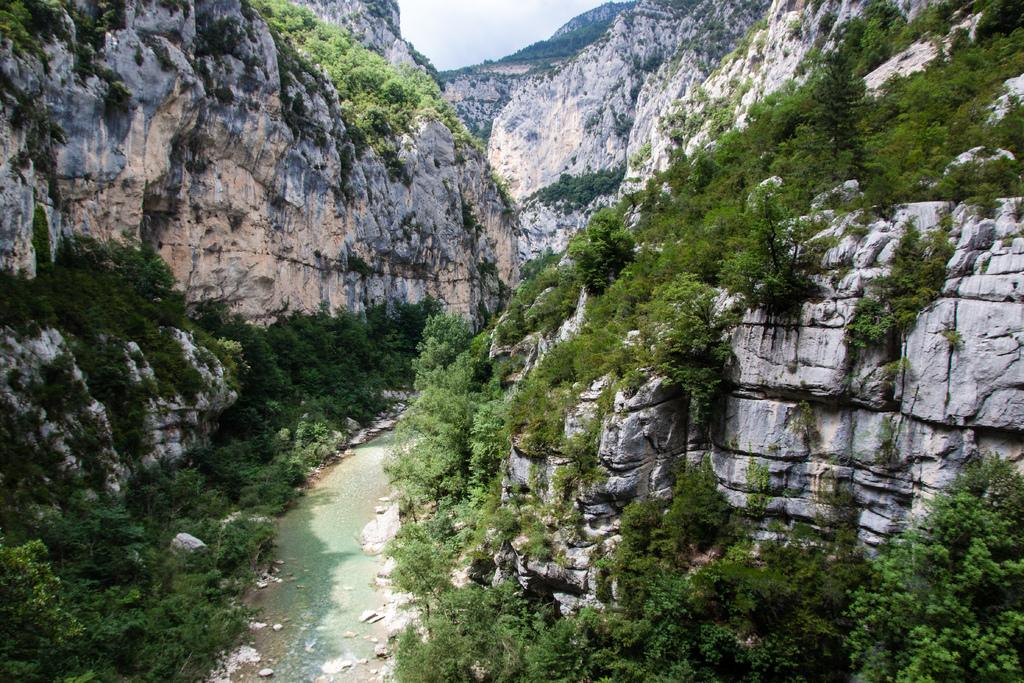What is the main feature at the center of the image? There is a flow of water at the center of the image. What can be seen on the left side of the image? There are trees and hills on the left side of the image. What can be seen on the right side of the image? There are trees and hills on the right side of the image. What is visible in the background of the image? The sky is visible in the background of the image. What type of appliance can be seen on the street in the image? There is no street or appliance present in the image. 